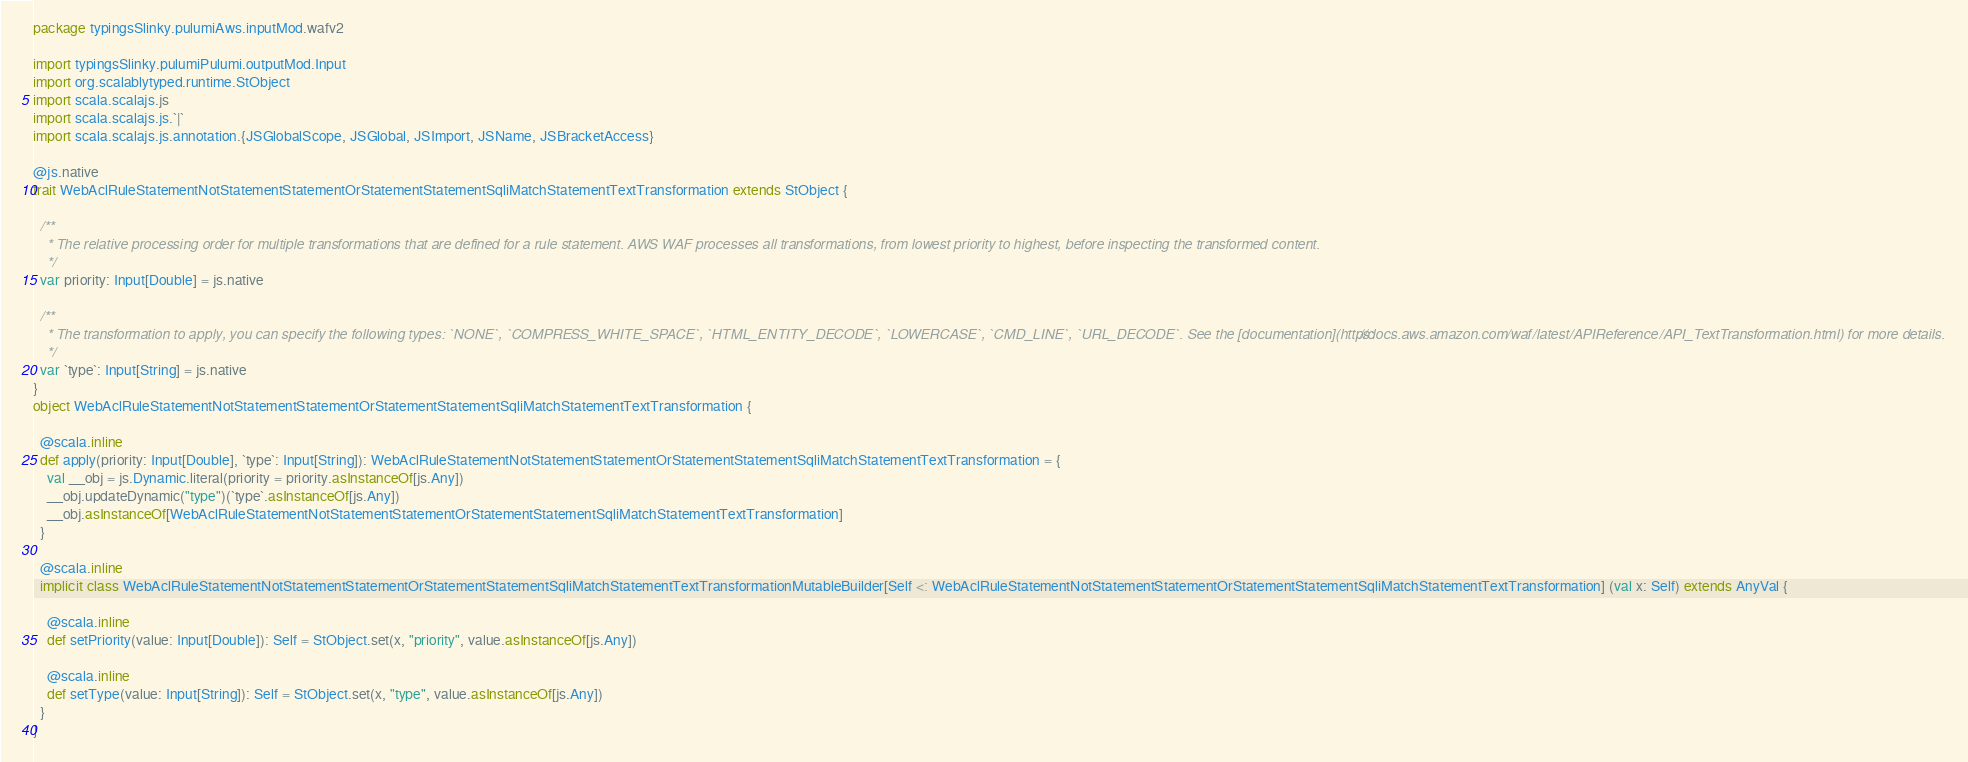<code> <loc_0><loc_0><loc_500><loc_500><_Scala_>package typingsSlinky.pulumiAws.inputMod.wafv2

import typingsSlinky.pulumiPulumi.outputMod.Input
import org.scalablytyped.runtime.StObject
import scala.scalajs.js
import scala.scalajs.js.`|`
import scala.scalajs.js.annotation.{JSGlobalScope, JSGlobal, JSImport, JSName, JSBracketAccess}

@js.native
trait WebAclRuleStatementNotStatementStatementOrStatementStatementSqliMatchStatementTextTransformation extends StObject {
  
  /**
    * The relative processing order for multiple transformations that are defined for a rule statement. AWS WAF processes all transformations, from lowest priority to highest, before inspecting the transformed content.
    */
  var priority: Input[Double] = js.native
  
  /**
    * The transformation to apply, you can specify the following types: `NONE`, `COMPRESS_WHITE_SPACE`, `HTML_ENTITY_DECODE`, `LOWERCASE`, `CMD_LINE`, `URL_DECODE`. See the [documentation](https://docs.aws.amazon.com/waf/latest/APIReference/API_TextTransformation.html) for more details.
    */
  var `type`: Input[String] = js.native
}
object WebAclRuleStatementNotStatementStatementOrStatementStatementSqliMatchStatementTextTransformation {
  
  @scala.inline
  def apply(priority: Input[Double], `type`: Input[String]): WebAclRuleStatementNotStatementStatementOrStatementStatementSqliMatchStatementTextTransformation = {
    val __obj = js.Dynamic.literal(priority = priority.asInstanceOf[js.Any])
    __obj.updateDynamic("type")(`type`.asInstanceOf[js.Any])
    __obj.asInstanceOf[WebAclRuleStatementNotStatementStatementOrStatementStatementSqliMatchStatementTextTransformation]
  }
  
  @scala.inline
  implicit class WebAclRuleStatementNotStatementStatementOrStatementStatementSqliMatchStatementTextTransformationMutableBuilder[Self <: WebAclRuleStatementNotStatementStatementOrStatementStatementSqliMatchStatementTextTransformation] (val x: Self) extends AnyVal {
    
    @scala.inline
    def setPriority(value: Input[Double]): Self = StObject.set(x, "priority", value.asInstanceOf[js.Any])
    
    @scala.inline
    def setType(value: Input[String]): Self = StObject.set(x, "type", value.asInstanceOf[js.Any])
  }
}
</code> 